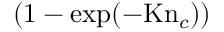Convert formula to latex. <formula><loc_0><loc_0><loc_500><loc_500>( 1 - \exp ( - K n _ { c } ) )</formula> 